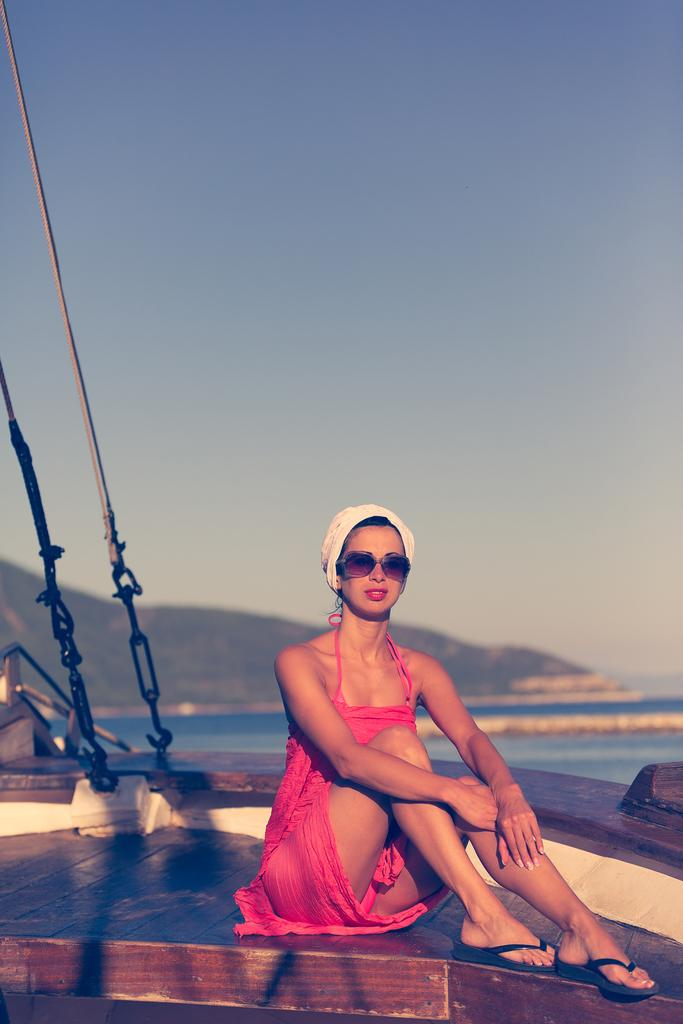Who is present in the image? There is a woman in the image. What is the woman wearing? The woman is wearing a pink dress. What is the woman doing in the image? The woman is sitting. What can be seen behind the woman? There is water visible behind the woman. What is in the distance in the image? There is a mountain in the background of the image. What type of knowledge is the woman carrying in a basket in the image? There is no basket or knowledge present in the image; the woman is simply sitting with a pink dress on. 